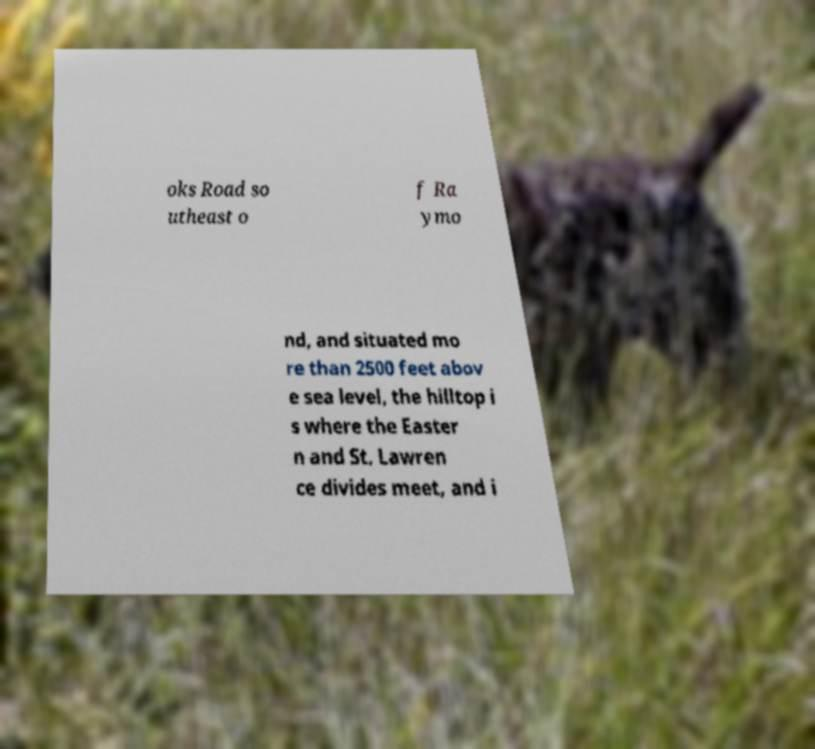For documentation purposes, I need the text within this image transcribed. Could you provide that? oks Road so utheast o f Ra ymo nd, and situated mo re than 2500 feet abov e sea level, the hilltop i s where the Easter n and St. Lawren ce divides meet, and i 